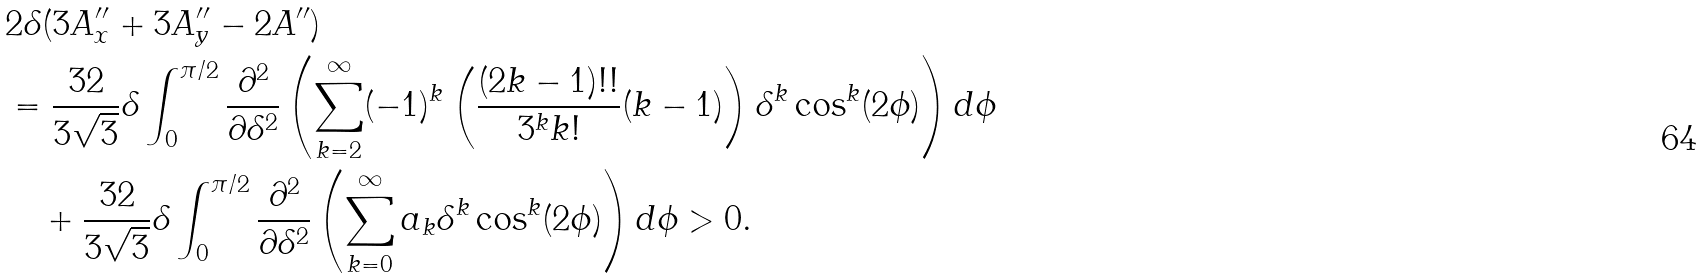Convert formula to latex. <formula><loc_0><loc_0><loc_500><loc_500>& 2 \delta ( 3 A _ { x } ^ { \prime \prime } + 3 A _ { y } ^ { \prime \prime } - 2 A ^ { \prime \prime } ) \\ & = \frac { 3 2 } { 3 \sqrt { 3 } } \delta \int _ { 0 } ^ { \pi / 2 } \frac { \partial ^ { 2 } } { \partial \delta ^ { 2 } } \left ( \sum _ { k = 2 } ^ { \infty } ( - 1 ) ^ { k } \left ( \frac { ( 2 k - 1 ) ! ! } { 3 ^ { k } k ! } ( k - 1 ) \right ) \delta ^ { k } \cos ^ { k } ( 2 \phi ) \right ) d \phi \\ & \quad + \frac { 3 2 } { 3 \sqrt { 3 } } \delta \int _ { 0 } ^ { \pi / 2 } \frac { \partial ^ { 2 } } { \partial \delta ^ { 2 } } \left ( \sum _ { k = 0 } ^ { \infty } a _ { k } \delta ^ { k } \cos ^ { k } ( 2 \phi ) \right ) d \phi > 0 .</formula> 